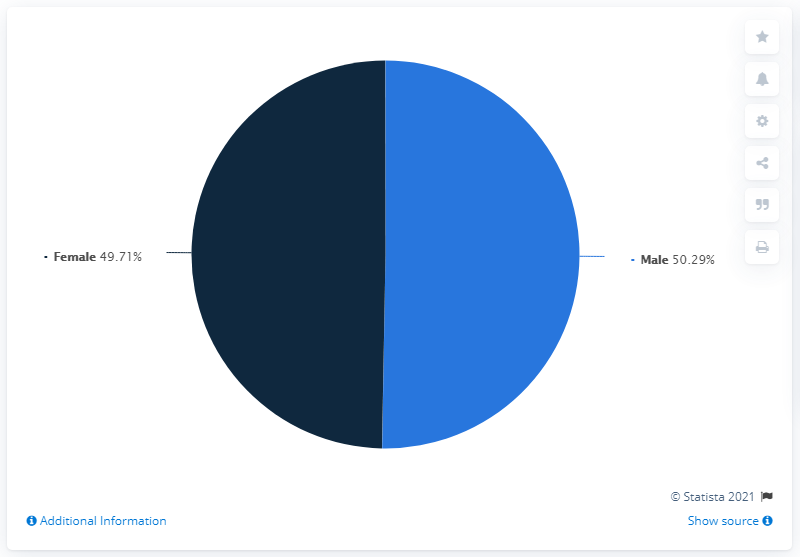Indicate a few pertinent items in this graphic. As of June 24, 2021, male patients accounted for 50.29% of the total number of confirmed coronavirus cases in South Korea. The percentage of COVID-19 cases in South Korea by gender on June 24, 2021, was 0.58, indicating a higher proportion of cases among males compared to females. As of June 24, 2021, among the confirmed 153 thousand coronavirus patients in South Korea, 50.29% were male. 